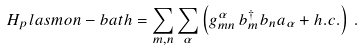<formula> <loc_0><loc_0><loc_500><loc_500>H _ { p } l a s m o n - b a t h = \sum _ { m , n } \sum _ { \alpha } \left ( g _ { m n } ^ { \alpha } \, b _ { m } ^ { \dag } b _ { n } a _ { \alpha } + h . c . \right ) \, .</formula> 